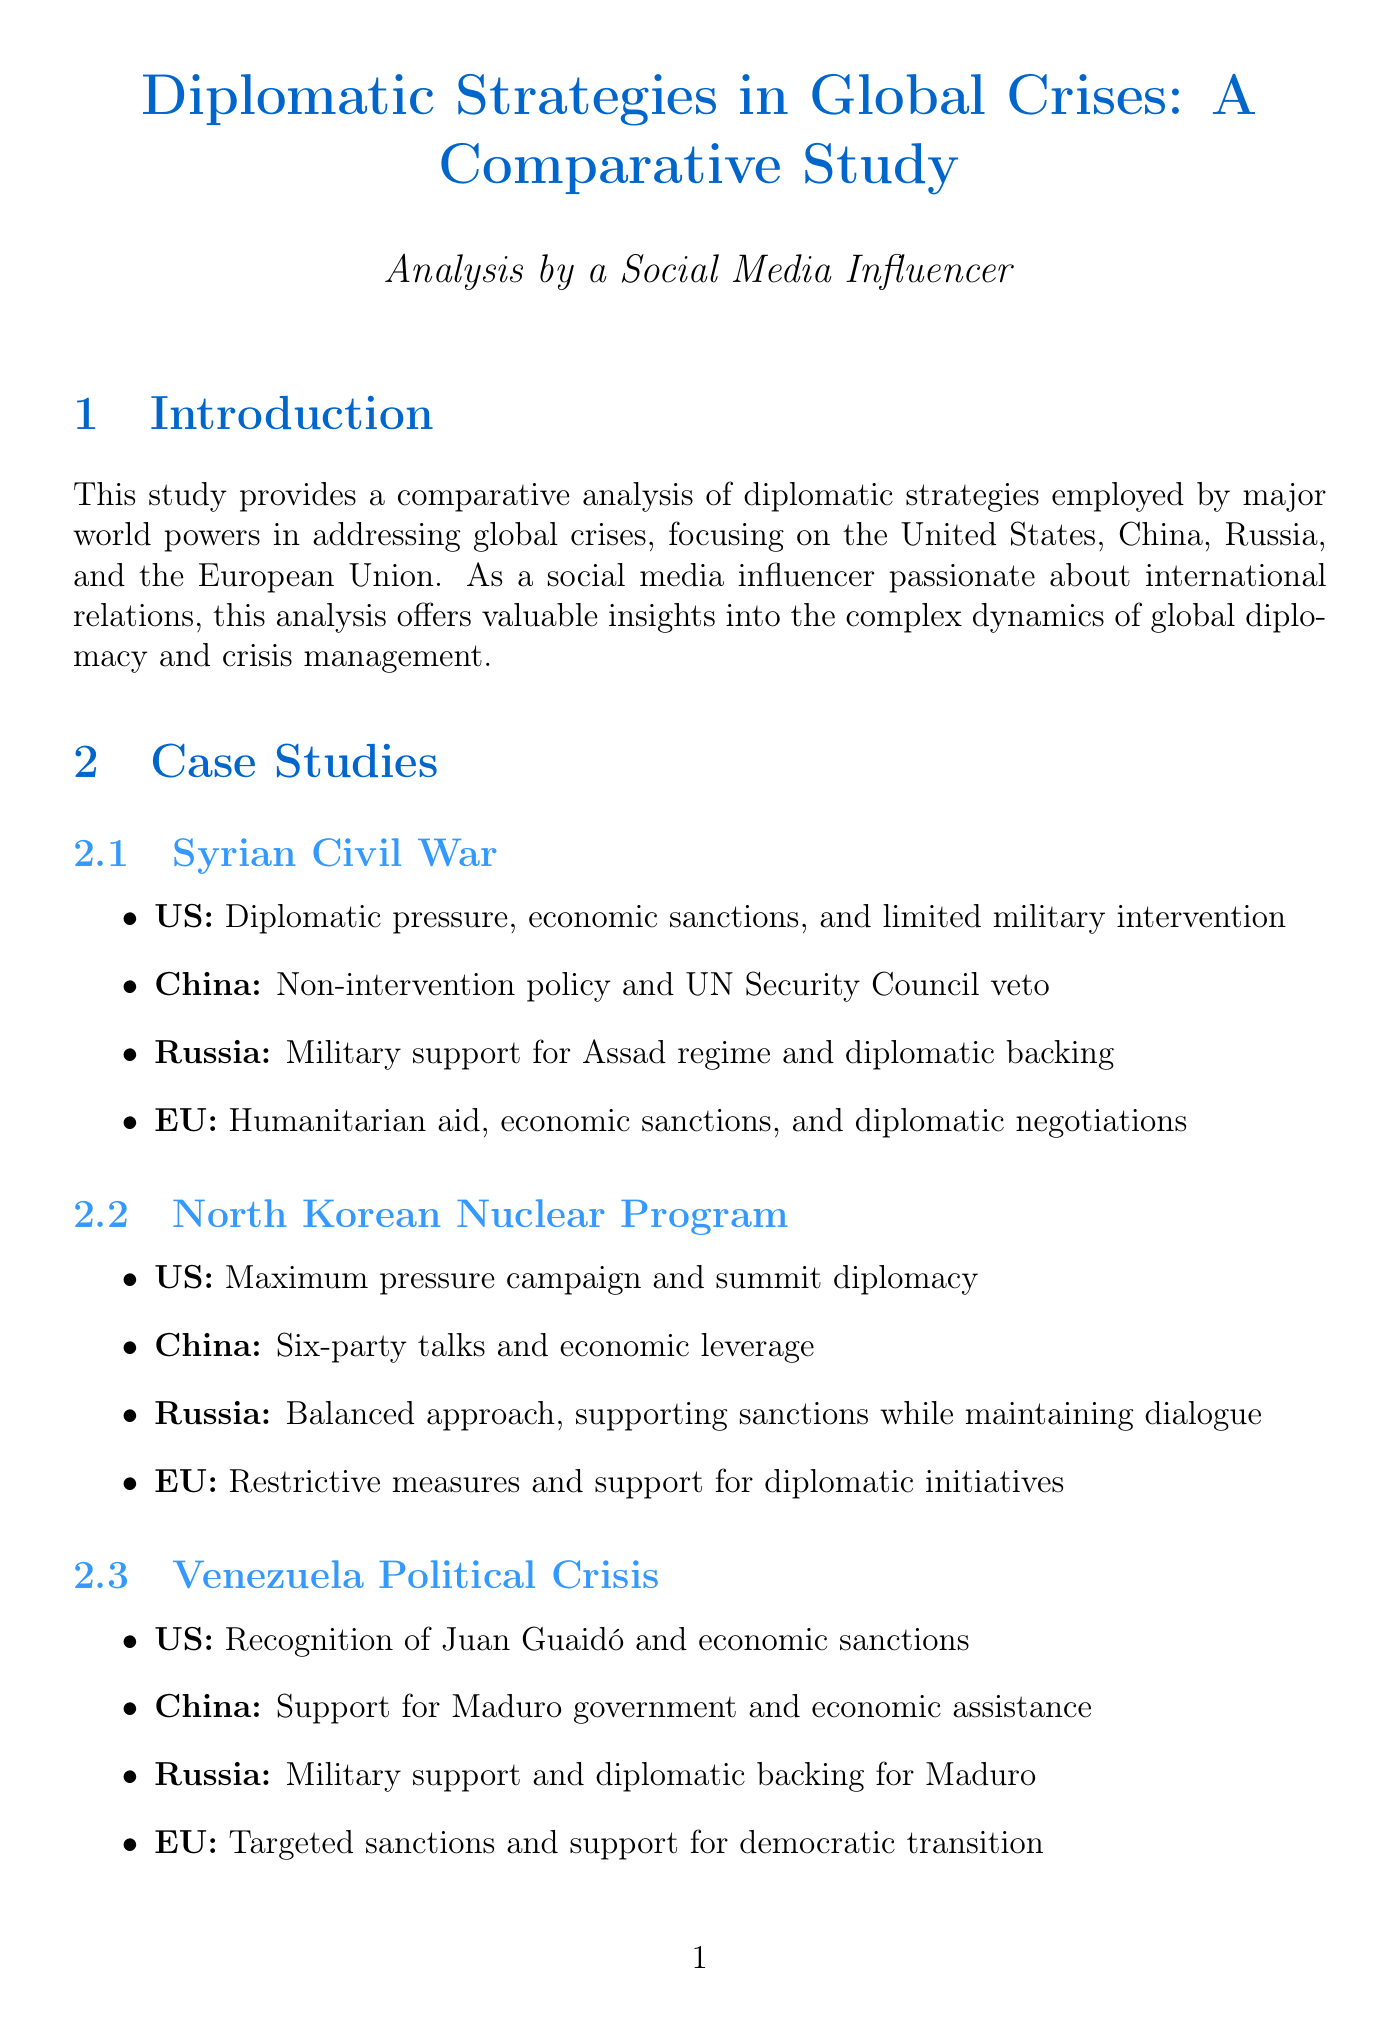What are the main world powers analyzed in the report? The report focuses on the diplomatic strategies of the United States, China, Russia, and the European Union.
Answer: United States, China, Russia, European Union Which crisis did the US recognize Juan Guaidó during? This recognition was part of the US strategy in the Venezuela Political Crisis.
Answer: Venezuela Political Crisis What diplomatic tool is noted for being a forum for multilateral negotiations? The document highlights the role of the United Nations as a key diplomatic tool.
Answer: United Nations Who is the US Secretary of State mentioned in the report? The report identifies Antony Blinken as the current US Secretary of State.
Answer: Antony Blinken What was the primary strategy of China regarding the Syrian Civil War? China adhered to a non-intervention policy and utilized its UN Security Council veto.
Answer: Non-intervention policy and UN Security Council veto What is the balance evaluated in the analysis section of the report? The analysis evaluates the balance between soft power and hard power approaches in crisis management.
Answer: Soft power and hard power What significant event does the term "maximum pressure campaign" refer to? It refers to the US strategy in addressing the North Korean Nuclear Program.
Answer: North Korean Nuclear Program What role does NATO play in global crises according to the report? NATO is described as a military alliance involved in crisis management and collective defense.
Answer: Military alliance What was a notable action taken by Russian Foreign Minister Sergey Lavrov? Sergey Lavrov is noted for asserting Russia's global influence and managing relations with the West.
Answer: Asserting Russia's global influence 